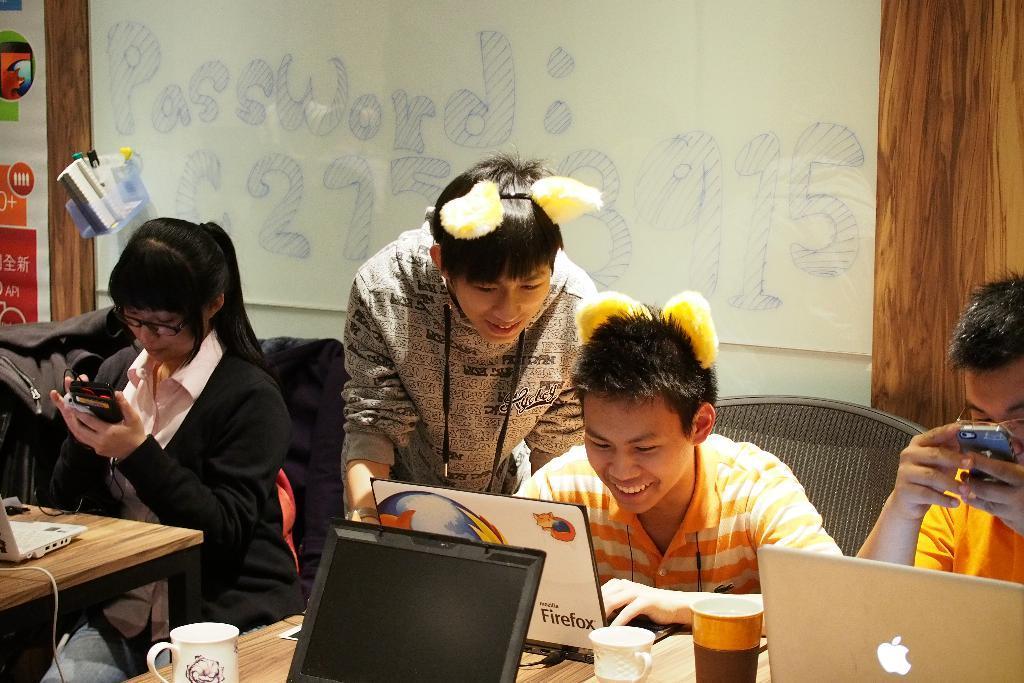Describe this image in one or two sentences. In the foreground of the picture we can see people, laptops, table, cups, chairs, bags and other objects. In the background we can see board, wall, poster, pens and other objects. 